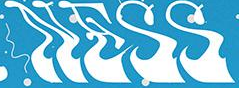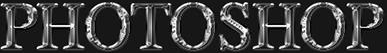What text appears in these images from left to right, separated by a semicolon? NESS; PHOTOSHOP 